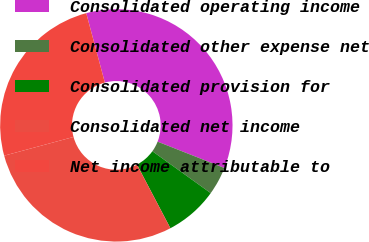Convert chart. <chart><loc_0><loc_0><loc_500><loc_500><pie_chart><fcel>Consolidated operating income<fcel>Consolidated other expense net<fcel>Consolidated provision for<fcel>Consolidated net income<fcel>Net income attributable to<nl><fcel>35.15%<fcel>3.93%<fcel>7.39%<fcel>28.5%<fcel>25.03%<nl></chart> 